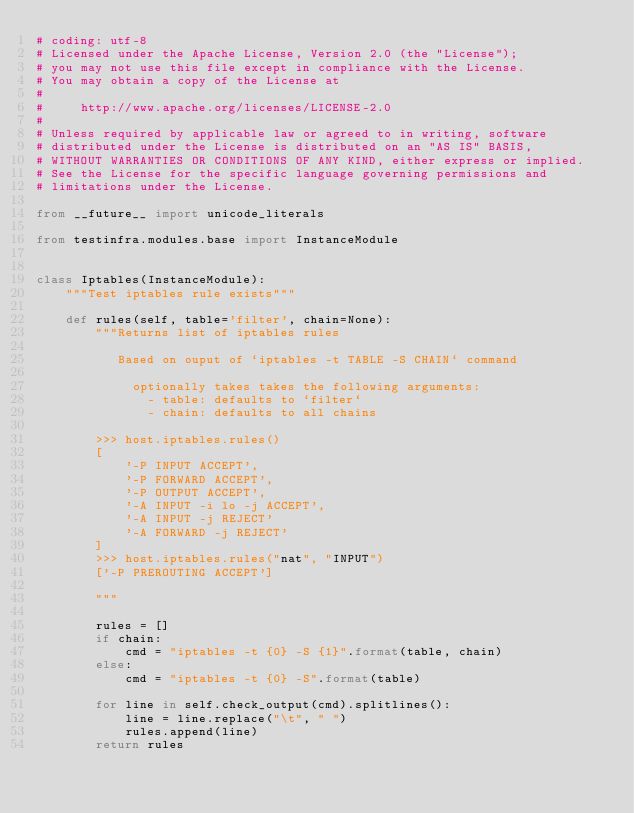<code> <loc_0><loc_0><loc_500><loc_500><_Python_># coding: utf-8
# Licensed under the Apache License, Version 2.0 (the "License");
# you may not use this file except in compliance with the License.
# You may obtain a copy of the License at
#
#     http://www.apache.org/licenses/LICENSE-2.0
#
# Unless required by applicable law or agreed to in writing, software
# distributed under the License is distributed on an "AS IS" BASIS,
# WITHOUT WARRANTIES OR CONDITIONS OF ANY KIND, either express or implied.
# See the License for the specific language governing permissions and
# limitations under the License.

from __future__ import unicode_literals

from testinfra.modules.base import InstanceModule


class Iptables(InstanceModule):
    """Test iptables rule exists"""

    def rules(self, table='filter', chain=None):
        """Returns list of iptables rules

           Based on ouput of `iptables -t TABLE -S CHAIN` command

             optionally takes takes the following arguments:
               - table: defaults to `filter`
               - chain: defaults to all chains

        >>> host.iptables.rules()
        [
            '-P INPUT ACCEPT',
            '-P FORWARD ACCEPT',
            '-P OUTPUT ACCEPT',
            '-A INPUT -i lo -j ACCEPT',
            '-A INPUT -j REJECT'
            '-A FORWARD -j REJECT'
        ]
        >>> host.iptables.rules("nat", "INPUT")
        ['-P PREROUTING ACCEPT']

        """

        rules = []
        if chain:
            cmd = "iptables -t {0} -S {1}".format(table, chain)
        else:
            cmd = "iptables -t {0} -S".format(table)

        for line in self.check_output(cmd).splitlines():
            line = line.replace("\t", " ")
            rules.append(line)
        return rules
</code> 